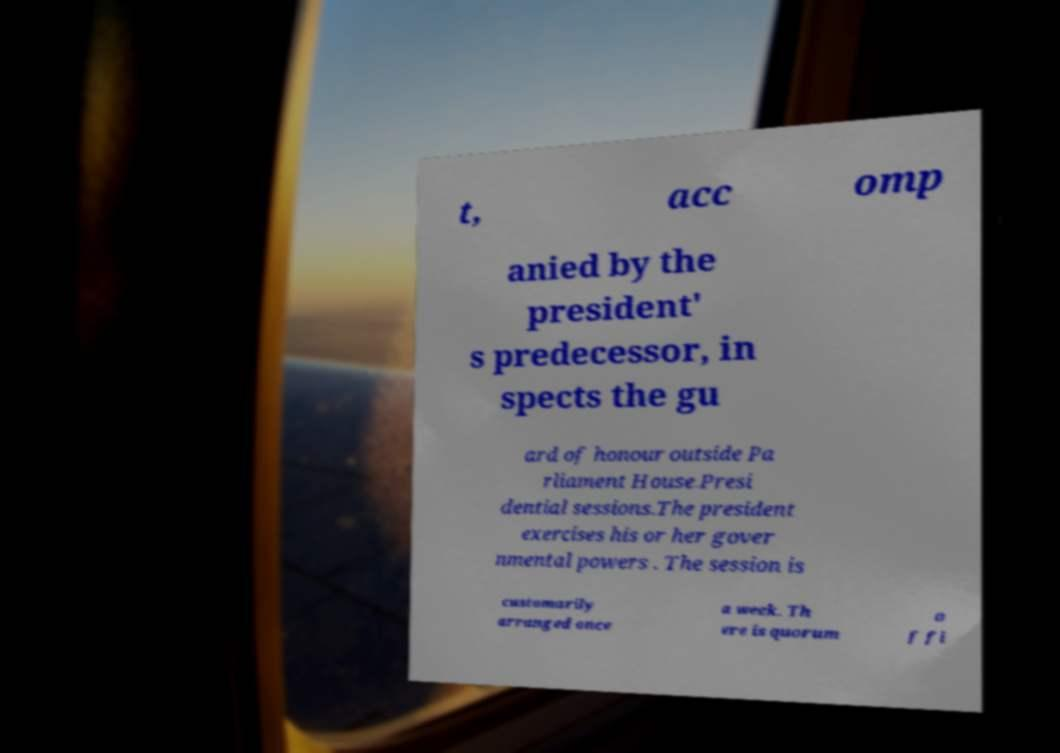Can you read and provide the text displayed in the image?This photo seems to have some interesting text. Can you extract and type it out for me? t, acc omp anied by the president' s predecessor, in spects the gu ard of honour outside Pa rliament House.Presi dential sessions.The president exercises his or her gover nmental powers . The session is customarily arranged once a week. Th ere is quorum o f fi 